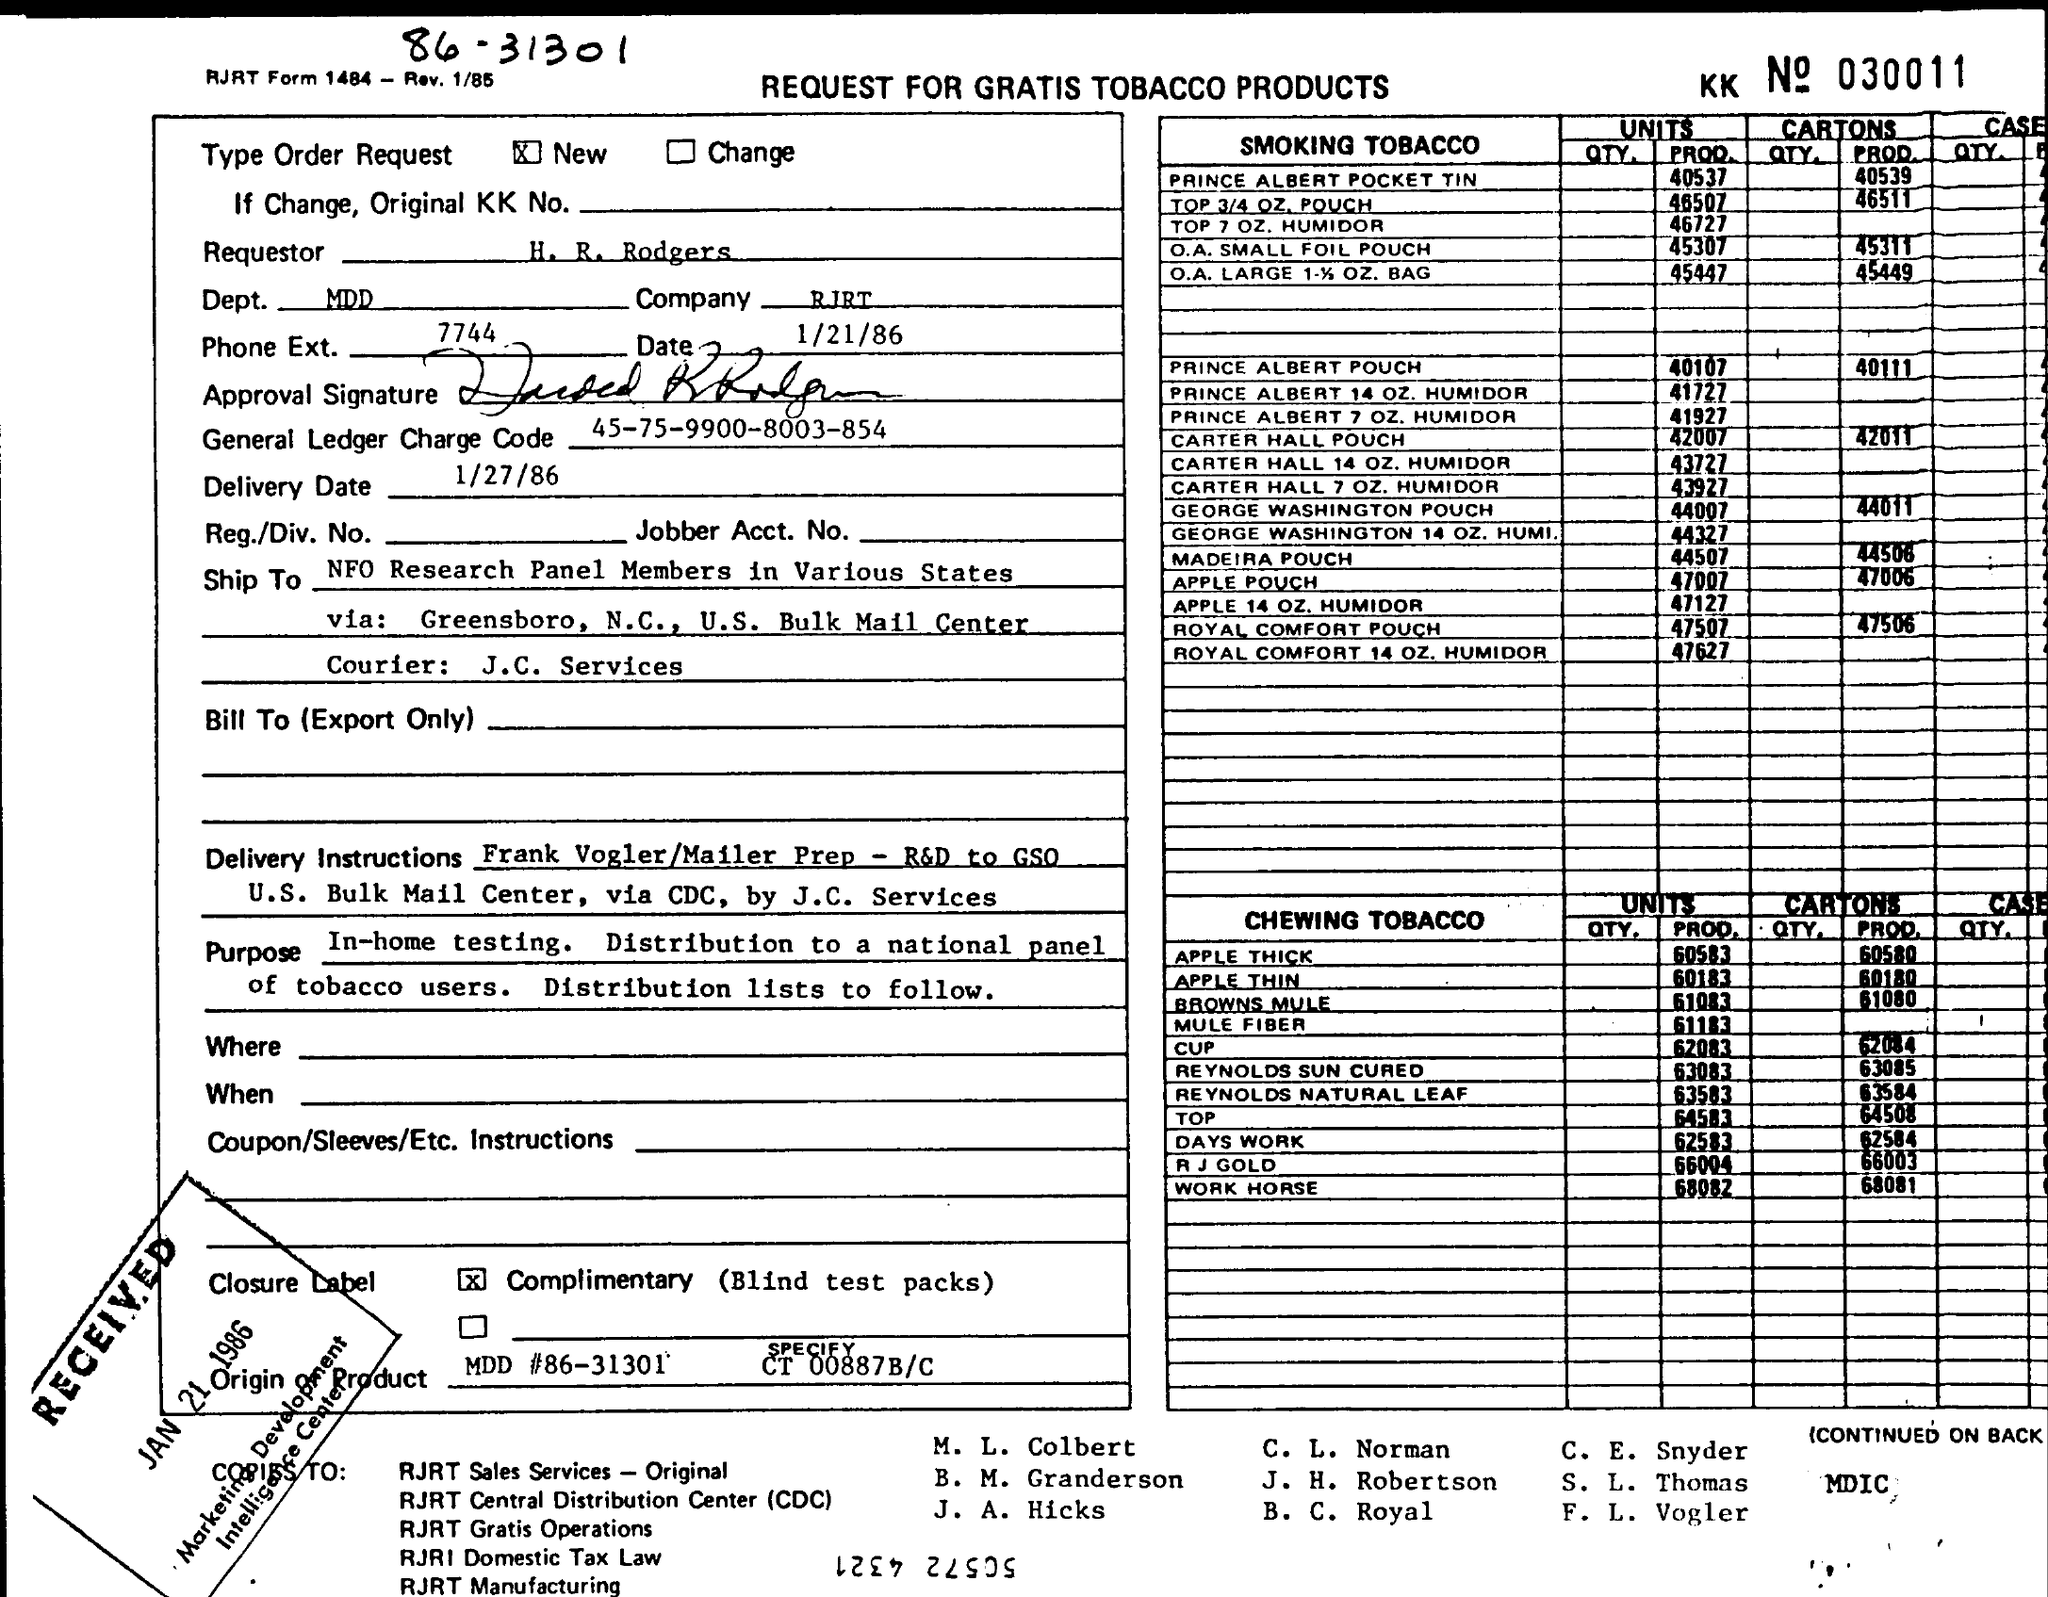What is the UNITS PROD of O.A.SMALL FOIL POUCH?
Keep it short and to the point. 45307. What is the name of Courier service used?
Offer a terse response. J.C. Services. Mention the number of CARTONS (PROD) of CHEWING TOBACCO in R.J GOLD?
Offer a very short reply. 66003. 